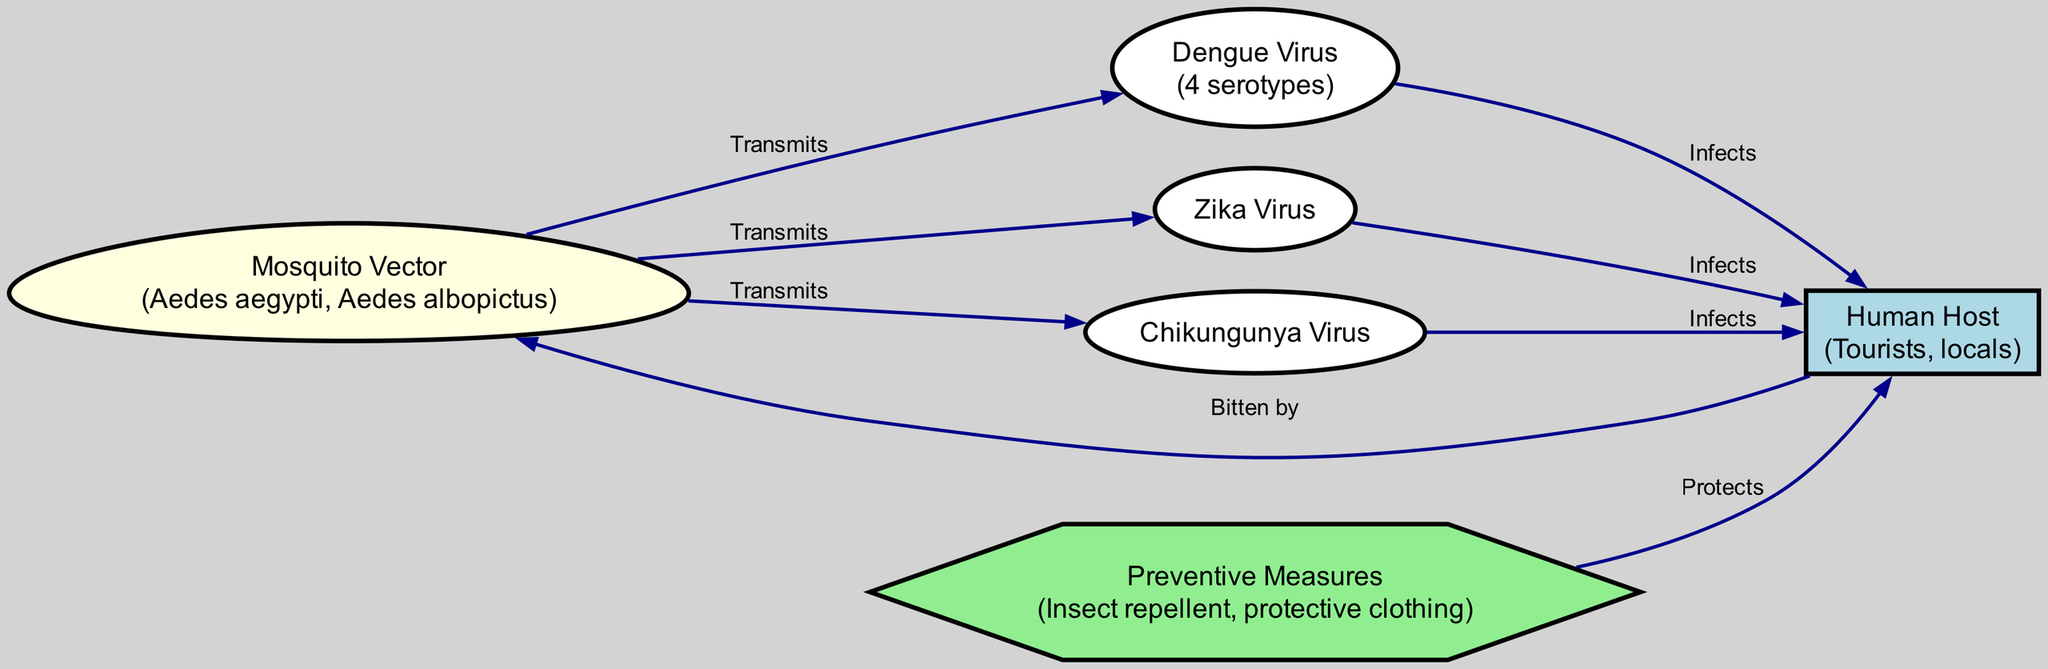What are the primary mosquito vectors depicted? The nodes in the diagram list two mosquito vectors: Aedes aegypti and Aedes albopictus, which are known for transmitting various viruses.
Answer: Aedes aegypti, Aedes albopictus How many viruses are transmitted by the mosquito vector? The diagram shows three viruses linked to the mosquito vector, specifically the Dengue virus, Zika virus, and Chikungunya virus.
Answer: Three Who is infected by the Dengue virus? According to the diagram, the Dengue virus infects the human host, which includes both tourists and locals in Southeast Asia.
Answer: Human Host What preventive measure is shown to protect against mosquito bites? The diagram indicates that insect repellent and protective clothing are the preventive measures mentioned, highlighting effective ways to decrease the risk of bites.
Answer: Insect repellent, protective clothing Which virus is transmitted by the mosquito vector and also infects humans? The diagram reveals that both the Dengue virus and Zika virus are transmitted by the mosquito vector and infect humans, but only one such virus can be selected to answer this question directly.
Answer: Dengue virus What is the role of the Human Host regarding the mosquito vector? The Human Host in the diagram is impacted when mosquitoes bite, turning this interaction into a cycle where the host can become infected by viruses carried by these mosquitoes.
Answer: Bitten by Which node represents the preventive measures? The diagram includes a node specifically labeled "Preventive Measures" which lists strategies used to avoid mosquito transmission and infection.
Answer: Preventive Measures How many edges are connected to the Mosquito Vector? By counting the edges that connect to the Mosquito Vector node, we can determine that there are three edges connecting it to the three viruses it transmits.
Answer: Three 